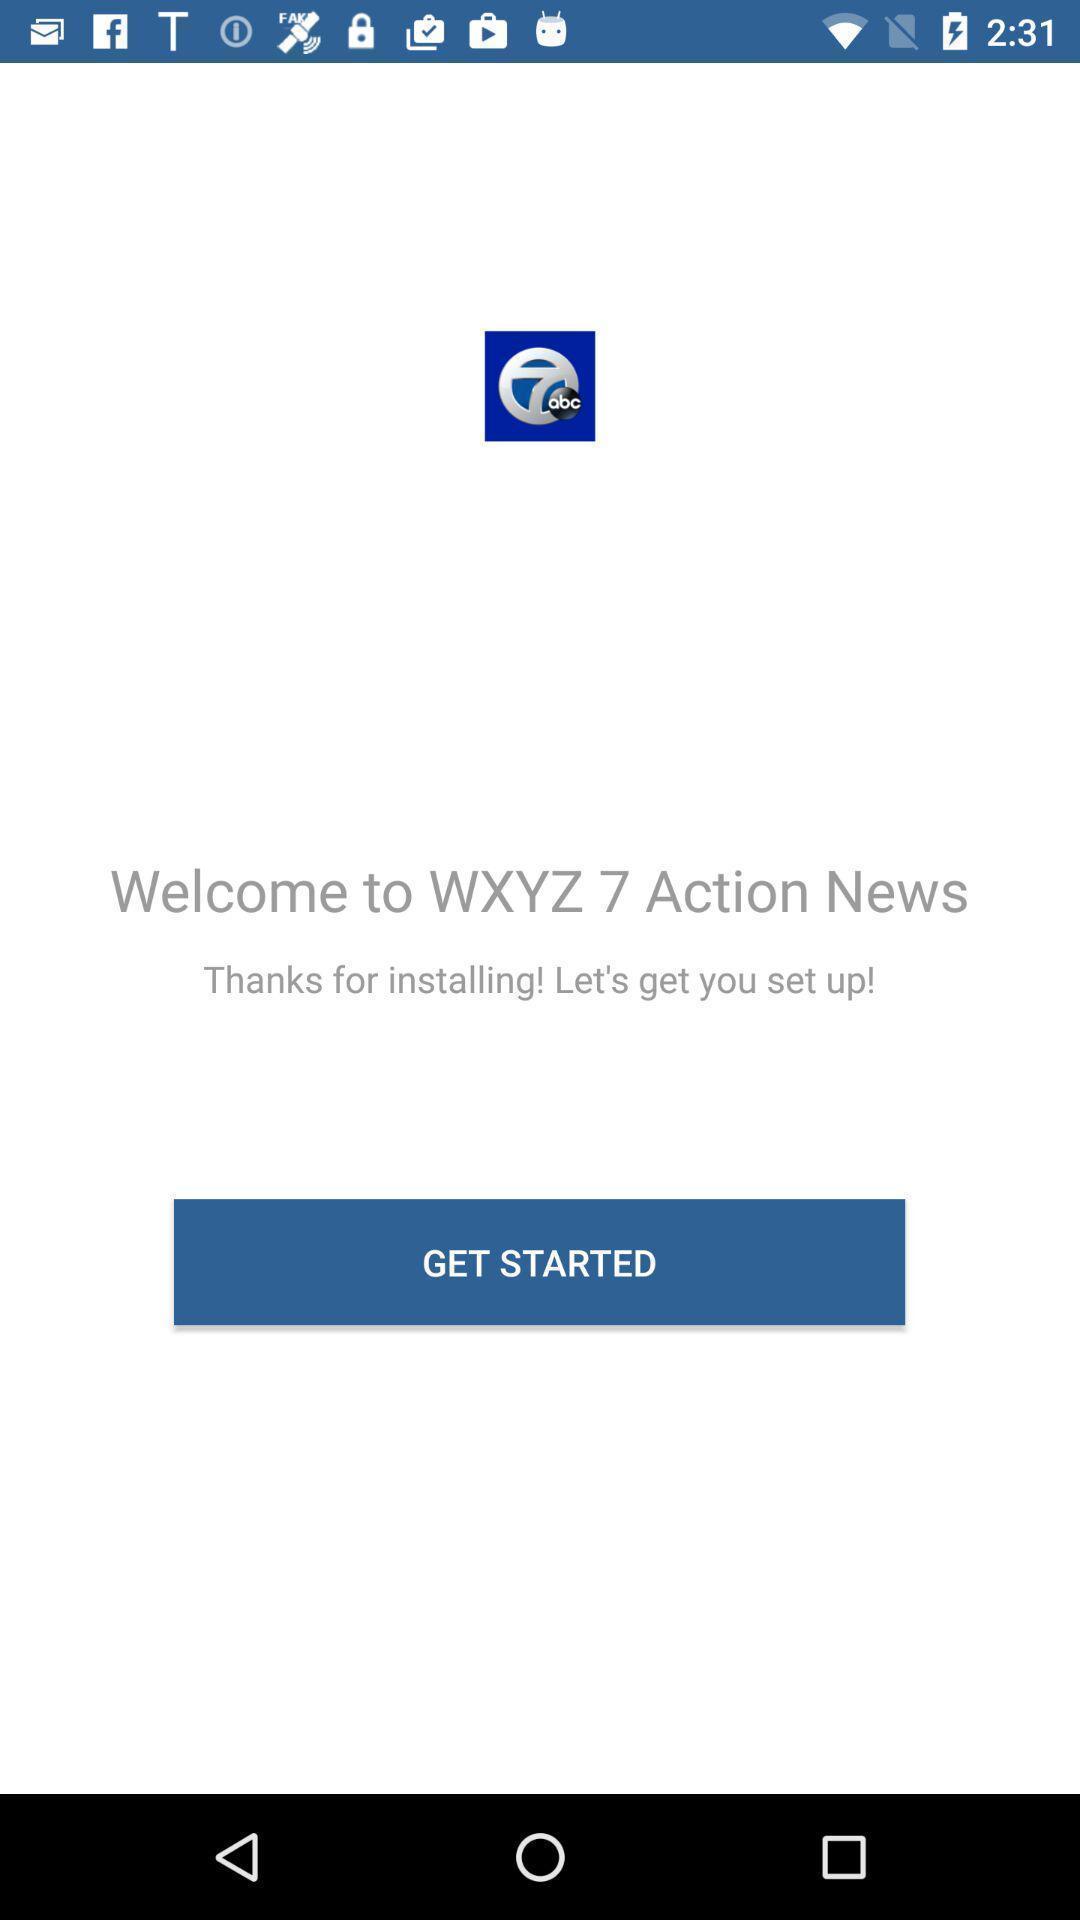Explain what's happening in this screen capture. Welcoming page. 